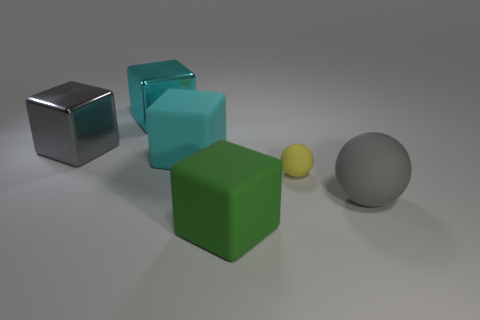Is there any other thing that is the same size as the yellow rubber thing?
Keep it short and to the point. No. There is another rubber object that is the same shape as the tiny yellow rubber object; what color is it?
Offer a terse response. Gray. Are there more large metal things in front of the green cube than large rubber spheres on the left side of the large gray metal cube?
Make the answer very short. No. How many other objects are the same shape as the big cyan shiny object?
Keep it short and to the point. 3. Are there any rubber cubes that are on the right side of the large matte cube that is behind the big sphere?
Keep it short and to the point. Yes. What number of gray blocks are there?
Your answer should be very brief. 1. Is the color of the small sphere the same as the big shiny block that is behind the large gray block?
Your response must be concise. No. Are there more cyan metallic objects than tiny blue rubber blocks?
Provide a short and direct response. Yes. Is there anything else that is the same color as the tiny sphere?
Offer a very short reply. No. How many other objects are there of the same size as the green matte block?
Make the answer very short. 4. 